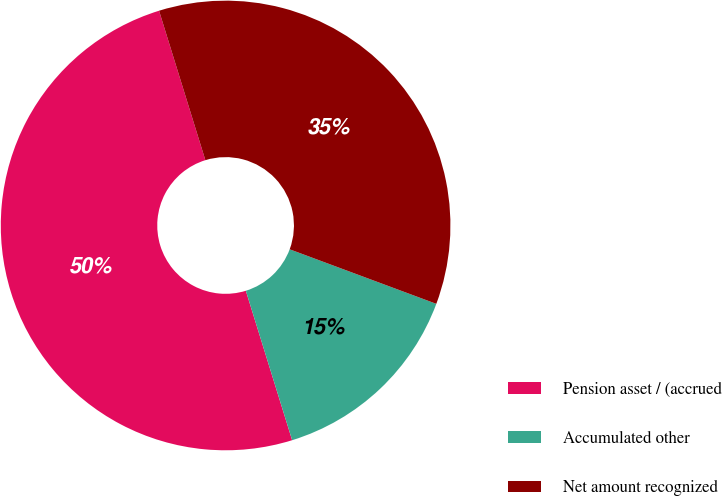Convert chart. <chart><loc_0><loc_0><loc_500><loc_500><pie_chart><fcel>Pension asset / (accrued<fcel>Accumulated other<fcel>Net amount recognized<nl><fcel>50.0%<fcel>14.55%<fcel>35.45%<nl></chart> 